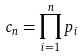<formula> <loc_0><loc_0><loc_500><loc_500>c _ { n } = \prod _ { i = 1 } ^ { n } p _ { i }</formula> 